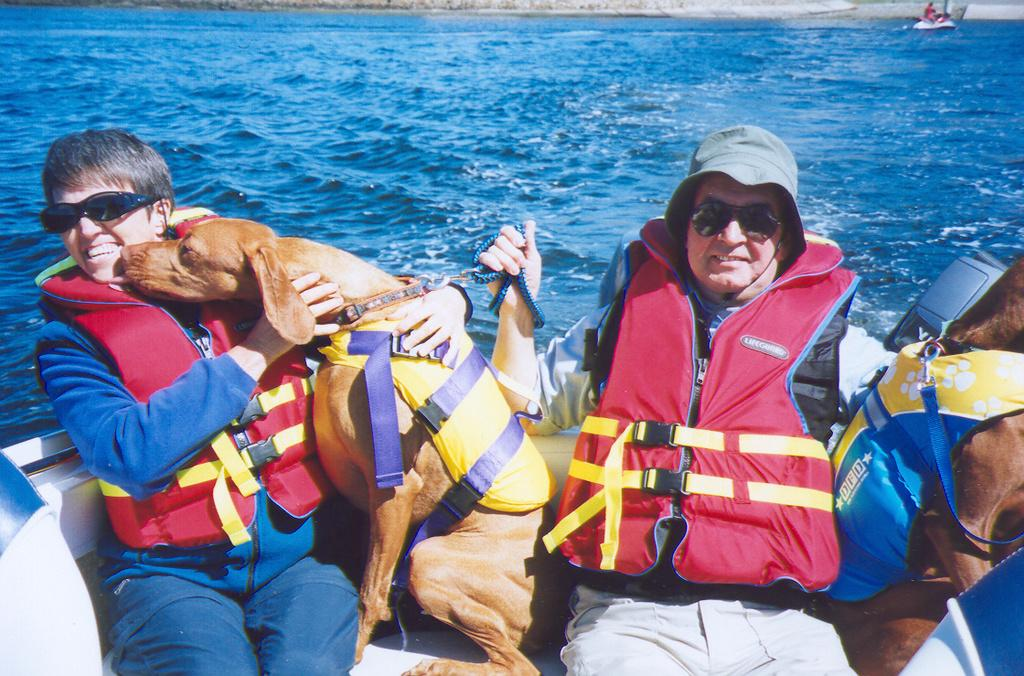What is the main subject in the foreground of the image? There is a boat in the foreground of the image. Who or what is inside the boat? There are two persons and two dogs in the boat. What can be seen in the background of the image? There is a beach and another boat in the background of the image. Where is the faucet located in the image? There is no faucet present in the image. What type of nut is being cracked by the dogs in the boat? There are no nuts or any activity involving nuts in the image. 